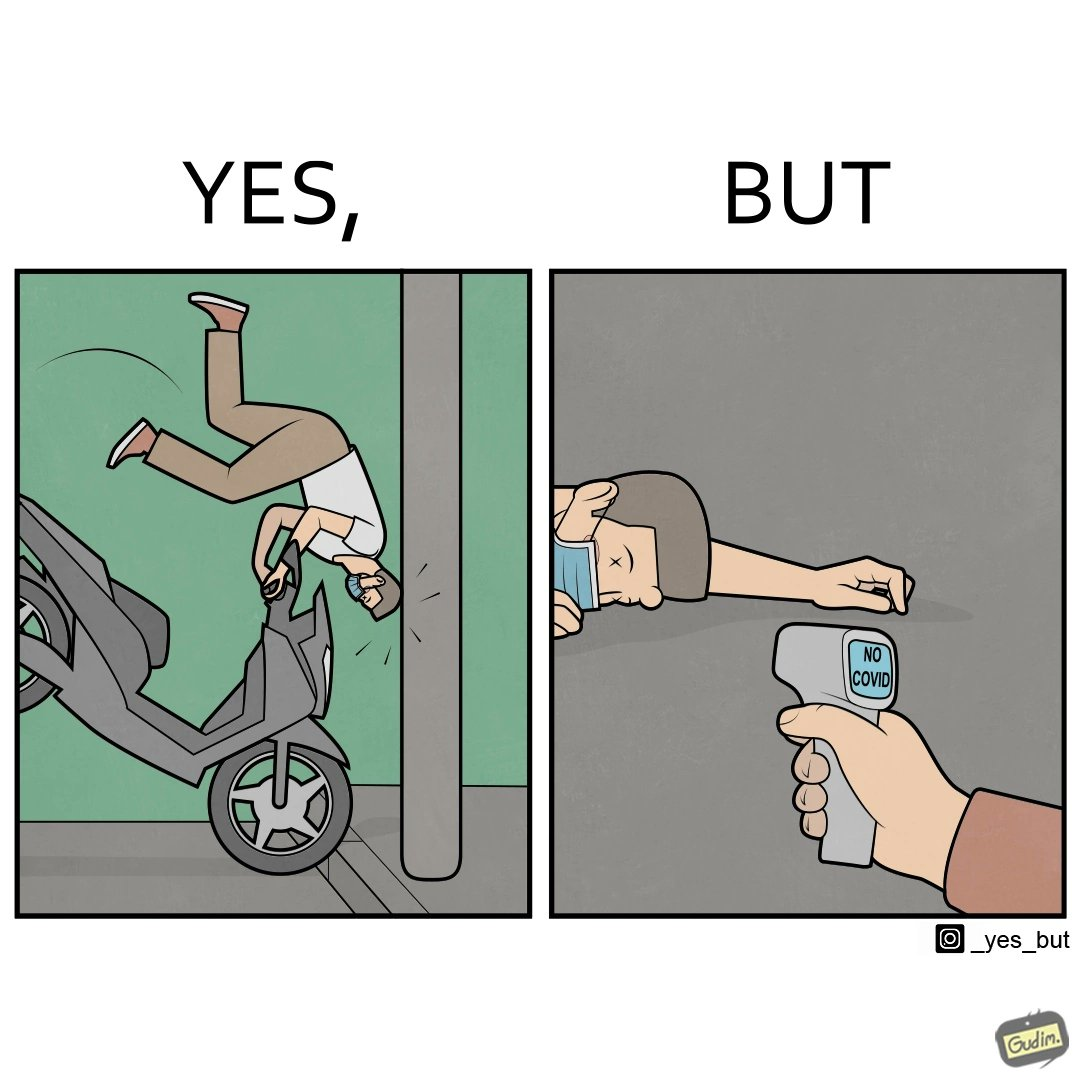What is the satirical meaning behind this image? the irony in the image comes from people trying to avoid covid, where a injured person is scanned for covid before they get help. 